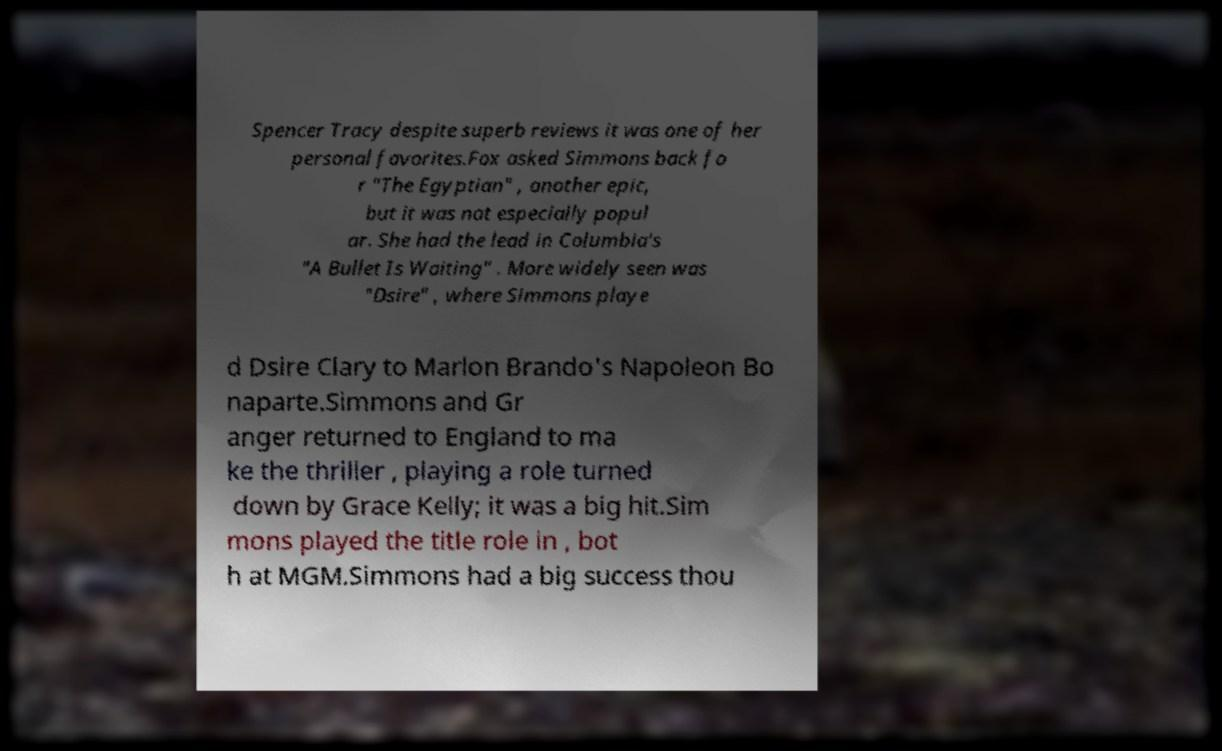What messages or text are displayed in this image? I need them in a readable, typed format. Spencer Tracy despite superb reviews it was one of her personal favorites.Fox asked Simmons back fo r "The Egyptian" , another epic, but it was not especially popul ar. She had the lead in Columbia's "A Bullet Is Waiting" . More widely seen was "Dsire" , where Simmons playe d Dsire Clary to Marlon Brando's Napoleon Bo naparte.Simmons and Gr anger returned to England to ma ke the thriller , playing a role turned down by Grace Kelly; it was a big hit.Sim mons played the title role in , bot h at MGM.Simmons had a big success thou 